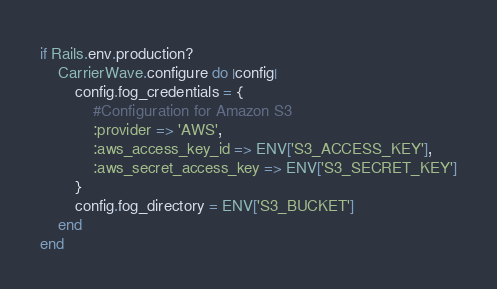<code> <loc_0><loc_0><loc_500><loc_500><_Ruby_>if Rails.env.production?
    CarrierWave.configure do |config|
        config.fog_credentials = {
            #Configuration for Amazon S3
            :provider => 'AWS',
            :aws_access_key_id => ENV['S3_ACCESS_KEY'],
            :aws_secret_access_key => ENV['S3_SECRET_KEY']
        }
        config.fog_directory = ENV['S3_BUCKET']
    end
end
</code> 